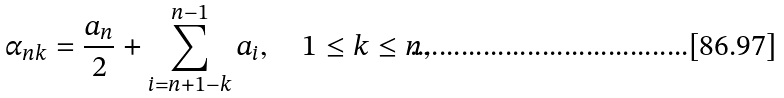Convert formula to latex. <formula><loc_0><loc_0><loc_500><loc_500>\alpha _ { n k } = \frac { a _ { n } } { 2 } + \sum _ { i = n + 1 - k } ^ { n - 1 } a _ { i } , \quad 1 \leq k \leq n ,</formula> 